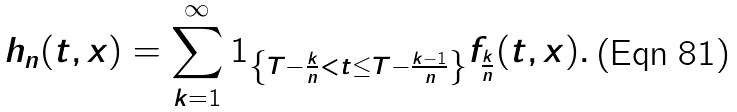Convert formula to latex. <formula><loc_0><loc_0><loc_500><loc_500>h _ { n } ( t , x ) = \sum _ { k = 1 } ^ { \infty } 1 _ { \left \{ T - \frac { k } { n } < t \leq T - \frac { k - 1 } { n } \right \} } f _ { \frac { k } { n } } ( t , x ) .</formula> 